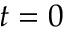Convert formula to latex. <formula><loc_0><loc_0><loc_500><loc_500>t = 0</formula> 